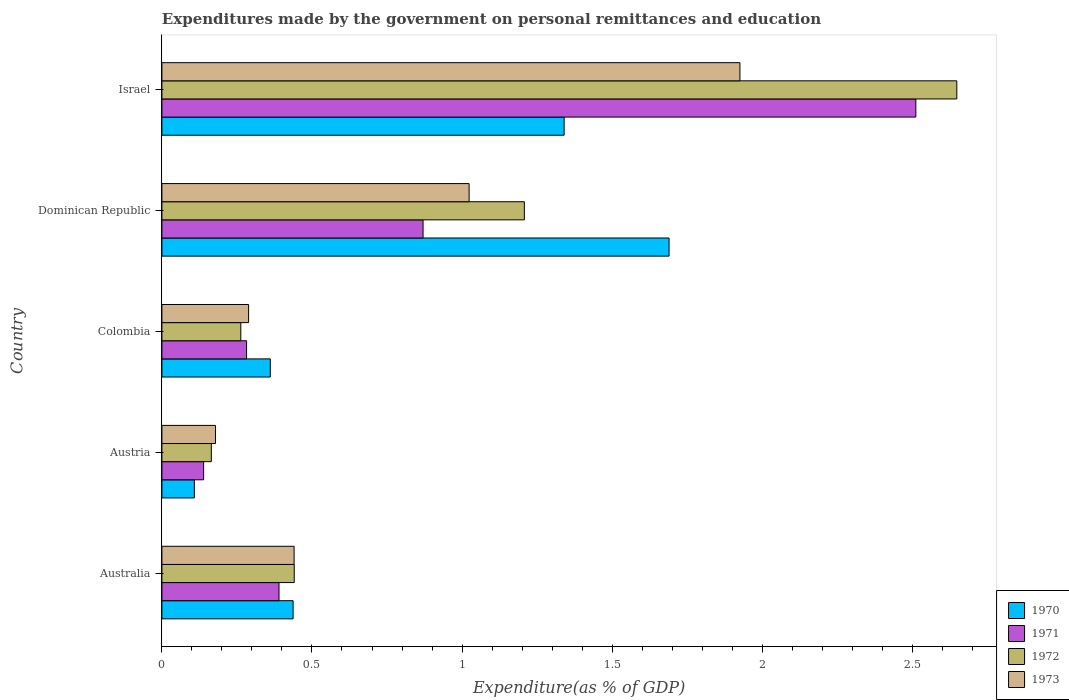How many groups of bars are there?
Your answer should be compact. 5. Are the number of bars per tick equal to the number of legend labels?
Your answer should be very brief. Yes. What is the label of the 2nd group of bars from the top?
Provide a short and direct response. Dominican Republic. In how many cases, is the number of bars for a given country not equal to the number of legend labels?
Provide a succinct answer. 0. What is the expenditures made by the government on personal remittances and education in 1973 in Australia?
Your answer should be compact. 0.44. Across all countries, what is the maximum expenditures made by the government on personal remittances and education in 1971?
Provide a succinct answer. 2.51. Across all countries, what is the minimum expenditures made by the government on personal remittances and education in 1971?
Keep it short and to the point. 0.14. What is the total expenditures made by the government on personal remittances and education in 1971 in the graph?
Ensure brevity in your answer.  4.19. What is the difference between the expenditures made by the government on personal remittances and education in 1971 in Australia and that in Dominican Republic?
Make the answer very short. -0.48. What is the difference between the expenditures made by the government on personal remittances and education in 1970 in Dominican Republic and the expenditures made by the government on personal remittances and education in 1971 in Israel?
Provide a short and direct response. -0.82. What is the average expenditures made by the government on personal remittances and education in 1973 per country?
Your response must be concise. 0.77. What is the difference between the expenditures made by the government on personal remittances and education in 1972 and expenditures made by the government on personal remittances and education in 1970 in Israel?
Keep it short and to the point. 1.31. In how many countries, is the expenditures made by the government on personal remittances and education in 1972 greater than 1.1 %?
Ensure brevity in your answer.  2. What is the ratio of the expenditures made by the government on personal remittances and education in 1973 in Colombia to that in Dominican Republic?
Offer a very short reply. 0.28. Is the expenditures made by the government on personal remittances and education in 1972 in Australia less than that in Colombia?
Provide a short and direct response. No. What is the difference between the highest and the second highest expenditures made by the government on personal remittances and education in 1972?
Keep it short and to the point. 1.44. What is the difference between the highest and the lowest expenditures made by the government on personal remittances and education in 1972?
Make the answer very short. 2.48. In how many countries, is the expenditures made by the government on personal remittances and education in 1970 greater than the average expenditures made by the government on personal remittances and education in 1970 taken over all countries?
Your response must be concise. 2. Is the sum of the expenditures made by the government on personal remittances and education in 1973 in Austria and Colombia greater than the maximum expenditures made by the government on personal remittances and education in 1972 across all countries?
Your answer should be compact. No. Is it the case that in every country, the sum of the expenditures made by the government on personal remittances and education in 1973 and expenditures made by the government on personal remittances and education in 1970 is greater than the sum of expenditures made by the government on personal remittances and education in 1972 and expenditures made by the government on personal remittances and education in 1971?
Keep it short and to the point. No. How many bars are there?
Offer a terse response. 20. Are the values on the major ticks of X-axis written in scientific E-notation?
Your response must be concise. No. What is the title of the graph?
Offer a terse response. Expenditures made by the government on personal remittances and education. What is the label or title of the X-axis?
Offer a very short reply. Expenditure(as % of GDP). What is the Expenditure(as % of GDP) in 1970 in Australia?
Keep it short and to the point. 0.44. What is the Expenditure(as % of GDP) in 1971 in Australia?
Offer a very short reply. 0.39. What is the Expenditure(as % of GDP) of 1972 in Australia?
Make the answer very short. 0.44. What is the Expenditure(as % of GDP) in 1973 in Australia?
Your answer should be compact. 0.44. What is the Expenditure(as % of GDP) of 1970 in Austria?
Keep it short and to the point. 0.11. What is the Expenditure(as % of GDP) of 1971 in Austria?
Make the answer very short. 0.14. What is the Expenditure(as % of GDP) in 1972 in Austria?
Your answer should be very brief. 0.16. What is the Expenditure(as % of GDP) of 1973 in Austria?
Offer a terse response. 0.18. What is the Expenditure(as % of GDP) in 1970 in Colombia?
Keep it short and to the point. 0.36. What is the Expenditure(as % of GDP) in 1971 in Colombia?
Give a very brief answer. 0.28. What is the Expenditure(as % of GDP) in 1972 in Colombia?
Make the answer very short. 0.26. What is the Expenditure(as % of GDP) in 1973 in Colombia?
Give a very brief answer. 0.29. What is the Expenditure(as % of GDP) in 1970 in Dominican Republic?
Offer a terse response. 1.69. What is the Expenditure(as % of GDP) in 1971 in Dominican Republic?
Your answer should be very brief. 0.87. What is the Expenditure(as % of GDP) of 1972 in Dominican Republic?
Provide a succinct answer. 1.21. What is the Expenditure(as % of GDP) in 1973 in Dominican Republic?
Your answer should be compact. 1.02. What is the Expenditure(as % of GDP) in 1970 in Israel?
Your answer should be compact. 1.34. What is the Expenditure(as % of GDP) in 1971 in Israel?
Provide a short and direct response. 2.51. What is the Expenditure(as % of GDP) of 1972 in Israel?
Ensure brevity in your answer.  2.65. What is the Expenditure(as % of GDP) in 1973 in Israel?
Your response must be concise. 1.93. Across all countries, what is the maximum Expenditure(as % of GDP) of 1970?
Provide a succinct answer. 1.69. Across all countries, what is the maximum Expenditure(as % of GDP) of 1971?
Your response must be concise. 2.51. Across all countries, what is the maximum Expenditure(as % of GDP) in 1972?
Give a very brief answer. 2.65. Across all countries, what is the maximum Expenditure(as % of GDP) in 1973?
Give a very brief answer. 1.93. Across all countries, what is the minimum Expenditure(as % of GDP) in 1970?
Keep it short and to the point. 0.11. Across all countries, what is the minimum Expenditure(as % of GDP) of 1971?
Provide a short and direct response. 0.14. Across all countries, what is the minimum Expenditure(as % of GDP) in 1972?
Provide a short and direct response. 0.16. Across all countries, what is the minimum Expenditure(as % of GDP) of 1973?
Ensure brevity in your answer.  0.18. What is the total Expenditure(as % of GDP) in 1970 in the graph?
Provide a succinct answer. 3.94. What is the total Expenditure(as % of GDP) in 1971 in the graph?
Offer a very short reply. 4.19. What is the total Expenditure(as % of GDP) of 1972 in the graph?
Give a very brief answer. 4.72. What is the total Expenditure(as % of GDP) in 1973 in the graph?
Keep it short and to the point. 3.86. What is the difference between the Expenditure(as % of GDP) in 1970 in Australia and that in Austria?
Give a very brief answer. 0.33. What is the difference between the Expenditure(as % of GDP) in 1971 in Australia and that in Austria?
Your response must be concise. 0.25. What is the difference between the Expenditure(as % of GDP) of 1972 in Australia and that in Austria?
Your answer should be very brief. 0.28. What is the difference between the Expenditure(as % of GDP) in 1973 in Australia and that in Austria?
Your response must be concise. 0.26. What is the difference between the Expenditure(as % of GDP) of 1970 in Australia and that in Colombia?
Ensure brevity in your answer.  0.08. What is the difference between the Expenditure(as % of GDP) of 1971 in Australia and that in Colombia?
Offer a terse response. 0.11. What is the difference between the Expenditure(as % of GDP) of 1972 in Australia and that in Colombia?
Your response must be concise. 0.18. What is the difference between the Expenditure(as % of GDP) in 1973 in Australia and that in Colombia?
Provide a succinct answer. 0.15. What is the difference between the Expenditure(as % of GDP) in 1970 in Australia and that in Dominican Republic?
Give a very brief answer. -1.25. What is the difference between the Expenditure(as % of GDP) in 1971 in Australia and that in Dominican Republic?
Give a very brief answer. -0.48. What is the difference between the Expenditure(as % of GDP) of 1972 in Australia and that in Dominican Republic?
Ensure brevity in your answer.  -0.77. What is the difference between the Expenditure(as % of GDP) in 1973 in Australia and that in Dominican Republic?
Your answer should be compact. -0.58. What is the difference between the Expenditure(as % of GDP) of 1970 in Australia and that in Israel?
Give a very brief answer. -0.9. What is the difference between the Expenditure(as % of GDP) in 1971 in Australia and that in Israel?
Make the answer very short. -2.12. What is the difference between the Expenditure(as % of GDP) of 1972 in Australia and that in Israel?
Provide a short and direct response. -2.21. What is the difference between the Expenditure(as % of GDP) of 1973 in Australia and that in Israel?
Ensure brevity in your answer.  -1.49. What is the difference between the Expenditure(as % of GDP) of 1970 in Austria and that in Colombia?
Offer a very short reply. -0.25. What is the difference between the Expenditure(as % of GDP) of 1971 in Austria and that in Colombia?
Give a very brief answer. -0.14. What is the difference between the Expenditure(as % of GDP) in 1972 in Austria and that in Colombia?
Provide a short and direct response. -0.1. What is the difference between the Expenditure(as % of GDP) of 1973 in Austria and that in Colombia?
Offer a very short reply. -0.11. What is the difference between the Expenditure(as % of GDP) in 1970 in Austria and that in Dominican Republic?
Provide a succinct answer. -1.58. What is the difference between the Expenditure(as % of GDP) of 1971 in Austria and that in Dominican Republic?
Offer a very short reply. -0.73. What is the difference between the Expenditure(as % of GDP) in 1972 in Austria and that in Dominican Republic?
Make the answer very short. -1.04. What is the difference between the Expenditure(as % of GDP) of 1973 in Austria and that in Dominican Republic?
Your answer should be compact. -0.84. What is the difference between the Expenditure(as % of GDP) of 1970 in Austria and that in Israel?
Your response must be concise. -1.23. What is the difference between the Expenditure(as % of GDP) of 1971 in Austria and that in Israel?
Your answer should be very brief. -2.37. What is the difference between the Expenditure(as % of GDP) of 1972 in Austria and that in Israel?
Provide a succinct answer. -2.48. What is the difference between the Expenditure(as % of GDP) in 1973 in Austria and that in Israel?
Make the answer very short. -1.75. What is the difference between the Expenditure(as % of GDP) of 1970 in Colombia and that in Dominican Republic?
Offer a very short reply. -1.33. What is the difference between the Expenditure(as % of GDP) of 1971 in Colombia and that in Dominican Republic?
Offer a terse response. -0.59. What is the difference between the Expenditure(as % of GDP) of 1972 in Colombia and that in Dominican Republic?
Offer a very short reply. -0.94. What is the difference between the Expenditure(as % of GDP) of 1973 in Colombia and that in Dominican Republic?
Make the answer very short. -0.73. What is the difference between the Expenditure(as % of GDP) in 1970 in Colombia and that in Israel?
Your answer should be very brief. -0.98. What is the difference between the Expenditure(as % of GDP) of 1971 in Colombia and that in Israel?
Ensure brevity in your answer.  -2.23. What is the difference between the Expenditure(as % of GDP) in 1972 in Colombia and that in Israel?
Make the answer very short. -2.39. What is the difference between the Expenditure(as % of GDP) in 1973 in Colombia and that in Israel?
Provide a succinct answer. -1.64. What is the difference between the Expenditure(as % of GDP) in 1970 in Dominican Republic and that in Israel?
Provide a succinct answer. 0.35. What is the difference between the Expenditure(as % of GDP) in 1971 in Dominican Republic and that in Israel?
Make the answer very short. -1.64. What is the difference between the Expenditure(as % of GDP) of 1972 in Dominican Republic and that in Israel?
Make the answer very short. -1.44. What is the difference between the Expenditure(as % of GDP) in 1973 in Dominican Republic and that in Israel?
Provide a short and direct response. -0.9. What is the difference between the Expenditure(as % of GDP) in 1970 in Australia and the Expenditure(as % of GDP) in 1971 in Austria?
Your response must be concise. 0.3. What is the difference between the Expenditure(as % of GDP) of 1970 in Australia and the Expenditure(as % of GDP) of 1972 in Austria?
Your response must be concise. 0.27. What is the difference between the Expenditure(as % of GDP) of 1970 in Australia and the Expenditure(as % of GDP) of 1973 in Austria?
Your response must be concise. 0.26. What is the difference between the Expenditure(as % of GDP) in 1971 in Australia and the Expenditure(as % of GDP) in 1972 in Austria?
Provide a succinct answer. 0.23. What is the difference between the Expenditure(as % of GDP) in 1971 in Australia and the Expenditure(as % of GDP) in 1973 in Austria?
Offer a terse response. 0.21. What is the difference between the Expenditure(as % of GDP) in 1972 in Australia and the Expenditure(as % of GDP) in 1973 in Austria?
Offer a very short reply. 0.26. What is the difference between the Expenditure(as % of GDP) in 1970 in Australia and the Expenditure(as % of GDP) in 1971 in Colombia?
Provide a succinct answer. 0.15. What is the difference between the Expenditure(as % of GDP) of 1970 in Australia and the Expenditure(as % of GDP) of 1972 in Colombia?
Offer a terse response. 0.17. What is the difference between the Expenditure(as % of GDP) of 1970 in Australia and the Expenditure(as % of GDP) of 1973 in Colombia?
Provide a short and direct response. 0.15. What is the difference between the Expenditure(as % of GDP) of 1971 in Australia and the Expenditure(as % of GDP) of 1972 in Colombia?
Offer a very short reply. 0.13. What is the difference between the Expenditure(as % of GDP) of 1971 in Australia and the Expenditure(as % of GDP) of 1973 in Colombia?
Provide a succinct answer. 0.1. What is the difference between the Expenditure(as % of GDP) of 1972 in Australia and the Expenditure(as % of GDP) of 1973 in Colombia?
Offer a very short reply. 0.15. What is the difference between the Expenditure(as % of GDP) in 1970 in Australia and the Expenditure(as % of GDP) in 1971 in Dominican Republic?
Offer a terse response. -0.43. What is the difference between the Expenditure(as % of GDP) of 1970 in Australia and the Expenditure(as % of GDP) of 1972 in Dominican Republic?
Keep it short and to the point. -0.77. What is the difference between the Expenditure(as % of GDP) of 1970 in Australia and the Expenditure(as % of GDP) of 1973 in Dominican Republic?
Provide a succinct answer. -0.59. What is the difference between the Expenditure(as % of GDP) of 1971 in Australia and the Expenditure(as % of GDP) of 1972 in Dominican Republic?
Your answer should be very brief. -0.82. What is the difference between the Expenditure(as % of GDP) in 1971 in Australia and the Expenditure(as % of GDP) in 1973 in Dominican Republic?
Ensure brevity in your answer.  -0.63. What is the difference between the Expenditure(as % of GDP) in 1972 in Australia and the Expenditure(as % of GDP) in 1973 in Dominican Republic?
Your response must be concise. -0.58. What is the difference between the Expenditure(as % of GDP) in 1970 in Australia and the Expenditure(as % of GDP) in 1971 in Israel?
Provide a short and direct response. -2.07. What is the difference between the Expenditure(as % of GDP) of 1970 in Australia and the Expenditure(as % of GDP) of 1972 in Israel?
Provide a succinct answer. -2.21. What is the difference between the Expenditure(as % of GDP) of 1970 in Australia and the Expenditure(as % of GDP) of 1973 in Israel?
Your response must be concise. -1.49. What is the difference between the Expenditure(as % of GDP) of 1971 in Australia and the Expenditure(as % of GDP) of 1972 in Israel?
Provide a succinct answer. -2.26. What is the difference between the Expenditure(as % of GDP) of 1971 in Australia and the Expenditure(as % of GDP) of 1973 in Israel?
Your answer should be very brief. -1.54. What is the difference between the Expenditure(as % of GDP) of 1972 in Australia and the Expenditure(as % of GDP) of 1973 in Israel?
Your answer should be very brief. -1.49. What is the difference between the Expenditure(as % of GDP) of 1970 in Austria and the Expenditure(as % of GDP) of 1971 in Colombia?
Offer a very short reply. -0.17. What is the difference between the Expenditure(as % of GDP) in 1970 in Austria and the Expenditure(as % of GDP) in 1972 in Colombia?
Offer a terse response. -0.15. What is the difference between the Expenditure(as % of GDP) in 1970 in Austria and the Expenditure(as % of GDP) in 1973 in Colombia?
Your answer should be very brief. -0.18. What is the difference between the Expenditure(as % of GDP) in 1971 in Austria and the Expenditure(as % of GDP) in 1972 in Colombia?
Make the answer very short. -0.12. What is the difference between the Expenditure(as % of GDP) in 1971 in Austria and the Expenditure(as % of GDP) in 1973 in Colombia?
Provide a short and direct response. -0.15. What is the difference between the Expenditure(as % of GDP) in 1972 in Austria and the Expenditure(as % of GDP) in 1973 in Colombia?
Offer a very short reply. -0.12. What is the difference between the Expenditure(as % of GDP) of 1970 in Austria and the Expenditure(as % of GDP) of 1971 in Dominican Republic?
Your response must be concise. -0.76. What is the difference between the Expenditure(as % of GDP) of 1970 in Austria and the Expenditure(as % of GDP) of 1972 in Dominican Republic?
Provide a short and direct response. -1.1. What is the difference between the Expenditure(as % of GDP) of 1970 in Austria and the Expenditure(as % of GDP) of 1973 in Dominican Republic?
Your answer should be compact. -0.92. What is the difference between the Expenditure(as % of GDP) of 1971 in Austria and the Expenditure(as % of GDP) of 1972 in Dominican Republic?
Keep it short and to the point. -1.07. What is the difference between the Expenditure(as % of GDP) of 1971 in Austria and the Expenditure(as % of GDP) of 1973 in Dominican Republic?
Keep it short and to the point. -0.88. What is the difference between the Expenditure(as % of GDP) of 1972 in Austria and the Expenditure(as % of GDP) of 1973 in Dominican Republic?
Offer a terse response. -0.86. What is the difference between the Expenditure(as % of GDP) in 1970 in Austria and the Expenditure(as % of GDP) in 1971 in Israel?
Offer a terse response. -2.4. What is the difference between the Expenditure(as % of GDP) in 1970 in Austria and the Expenditure(as % of GDP) in 1972 in Israel?
Offer a very short reply. -2.54. What is the difference between the Expenditure(as % of GDP) in 1970 in Austria and the Expenditure(as % of GDP) in 1973 in Israel?
Offer a very short reply. -1.82. What is the difference between the Expenditure(as % of GDP) of 1971 in Austria and the Expenditure(as % of GDP) of 1972 in Israel?
Your response must be concise. -2.51. What is the difference between the Expenditure(as % of GDP) of 1971 in Austria and the Expenditure(as % of GDP) of 1973 in Israel?
Provide a succinct answer. -1.79. What is the difference between the Expenditure(as % of GDP) of 1972 in Austria and the Expenditure(as % of GDP) of 1973 in Israel?
Your answer should be very brief. -1.76. What is the difference between the Expenditure(as % of GDP) in 1970 in Colombia and the Expenditure(as % of GDP) in 1971 in Dominican Republic?
Offer a very short reply. -0.51. What is the difference between the Expenditure(as % of GDP) of 1970 in Colombia and the Expenditure(as % of GDP) of 1972 in Dominican Republic?
Provide a succinct answer. -0.85. What is the difference between the Expenditure(as % of GDP) of 1970 in Colombia and the Expenditure(as % of GDP) of 1973 in Dominican Republic?
Provide a succinct answer. -0.66. What is the difference between the Expenditure(as % of GDP) in 1971 in Colombia and the Expenditure(as % of GDP) in 1972 in Dominican Republic?
Your response must be concise. -0.93. What is the difference between the Expenditure(as % of GDP) in 1971 in Colombia and the Expenditure(as % of GDP) in 1973 in Dominican Republic?
Provide a short and direct response. -0.74. What is the difference between the Expenditure(as % of GDP) in 1972 in Colombia and the Expenditure(as % of GDP) in 1973 in Dominican Republic?
Ensure brevity in your answer.  -0.76. What is the difference between the Expenditure(as % of GDP) in 1970 in Colombia and the Expenditure(as % of GDP) in 1971 in Israel?
Offer a very short reply. -2.15. What is the difference between the Expenditure(as % of GDP) of 1970 in Colombia and the Expenditure(as % of GDP) of 1972 in Israel?
Offer a very short reply. -2.29. What is the difference between the Expenditure(as % of GDP) of 1970 in Colombia and the Expenditure(as % of GDP) of 1973 in Israel?
Your answer should be very brief. -1.56. What is the difference between the Expenditure(as % of GDP) in 1971 in Colombia and the Expenditure(as % of GDP) in 1972 in Israel?
Provide a succinct answer. -2.37. What is the difference between the Expenditure(as % of GDP) in 1971 in Colombia and the Expenditure(as % of GDP) in 1973 in Israel?
Provide a short and direct response. -1.64. What is the difference between the Expenditure(as % of GDP) in 1972 in Colombia and the Expenditure(as % of GDP) in 1973 in Israel?
Offer a very short reply. -1.66. What is the difference between the Expenditure(as % of GDP) in 1970 in Dominican Republic and the Expenditure(as % of GDP) in 1971 in Israel?
Keep it short and to the point. -0.82. What is the difference between the Expenditure(as % of GDP) in 1970 in Dominican Republic and the Expenditure(as % of GDP) in 1972 in Israel?
Provide a short and direct response. -0.96. What is the difference between the Expenditure(as % of GDP) in 1970 in Dominican Republic and the Expenditure(as % of GDP) in 1973 in Israel?
Give a very brief answer. -0.24. What is the difference between the Expenditure(as % of GDP) of 1971 in Dominican Republic and the Expenditure(as % of GDP) of 1972 in Israel?
Offer a very short reply. -1.78. What is the difference between the Expenditure(as % of GDP) of 1971 in Dominican Republic and the Expenditure(as % of GDP) of 1973 in Israel?
Ensure brevity in your answer.  -1.06. What is the difference between the Expenditure(as % of GDP) in 1972 in Dominican Republic and the Expenditure(as % of GDP) in 1973 in Israel?
Provide a succinct answer. -0.72. What is the average Expenditure(as % of GDP) of 1970 per country?
Your answer should be compact. 0.79. What is the average Expenditure(as % of GDP) in 1971 per country?
Your answer should be compact. 0.84. What is the average Expenditure(as % of GDP) in 1972 per country?
Your response must be concise. 0.94. What is the average Expenditure(as % of GDP) in 1973 per country?
Offer a very short reply. 0.77. What is the difference between the Expenditure(as % of GDP) of 1970 and Expenditure(as % of GDP) of 1971 in Australia?
Give a very brief answer. 0.05. What is the difference between the Expenditure(as % of GDP) of 1970 and Expenditure(as % of GDP) of 1972 in Australia?
Your answer should be very brief. -0. What is the difference between the Expenditure(as % of GDP) of 1970 and Expenditure(as % of GDP) of 1973 in Australia?
Make the answer very short. -0. What is the difference between the Expenditure(as % of GDP) in 1971 and Expenditure(as % of GDP) in 1972 in Australia?
Your response must be concise. -0.05. What is the difference between the Expenditure(as % of GDP) of 1971 and Expenditure(as % of GDP) of 1973 in Australia?
Make the answer very short. -0.05. What is the difference between the Expenditure(as % of GDP) in 1972 and Expenditure(as % of GDP) in 1973 in Australia?
Offer a terse response. 0. What is the difference between the Expenditure(as % of GDP) of 1970 and Expenditure(as % of GDP) of 1971 in Austria?
Offer a terse response. -0.03. What is the difference between the Expenditure(as % of GDP) in 1970 and Expenditure(as % of GDP) in 1972 in Austria?
Offer a terse response. -0.06. What is the difference between the Expenditure(as % of GDP) of 1970 and Expenditure(as % of GDP) of 1973 in Austria?
Provide a short and direct response. -0.07. What is the difference between the Expenditure(as % of GDP) in 1971 and Expenditure(as % of GDP) in 1972 in Austria?
Ensure brevity in your answer.  -0.03. What is the difference between the Expenditure(as % of GDP) of 1971 and Expenditure(as % of GDP) of 1973 in Austria?
Provide a succinct answer. -0.04. What is the difference between the Expenditure(as % of GDP) in 1972 and Expenditure(as % of GDP) in 1973 in Austria?
Offer a very short reply. -0.01. What is the difference between the Expenditure(as % of GDP) of 1970 and Expenditure(as % of GDP) of 1971 in Colombia?
Offer a terse response. 0.08. What is the difference between the Expenditure(as % of GDP) in 1970 and Expenditure(as % of GDP) in 1972 in Colombia?
Your response must be concise. 0.1. What is the difference between the Expenditure(as % of GDP) in 1970 and Expenditure(as % of GDP) in 1973 in Colombia?
Your response must be concise. 0.07. What is the difference between the Expenditure(as % of GDP) in 1971 and Expenditure(as % of GDP) in 1972 in Colombia?
Keep it short and to the point. 0.02. What is the difference between the Expenditure(as % of GDP) of 1971 and Expenditure(as % of GDP) of 1973 in Colombia?
Offer a very short reply. -0.01. What is the difference between the Expenditure(as % of GDP) in 1972 and Expenditure(as % of GDP) in 1973 in Colombia?
Your answer should be compact. -0.03. What is the difference between the Expenditure(as % of GDP) in 1970 and Expenditure(as % of GDP) in 1971 in Dominican Republic?
Your response must be concise. 0.82. What is the difference between the Expenditure(as % of GDP) of 1970 and Expenditure(as % of GDP) of 1972 in Dominican Republic?
Your response must be concise. 0.48. What is the difference between the Expenditure(as % of GDP) of 1970 and Expenditure(as % of GDP) of 1973 in Dominican Republic?
Offer a very short reply. 0.67. What is the difference between the Expenditure(as % of GDP) of 1971 and Expenditure(as % of GDP) of 1972 in Dominican Republic?
Offer a very short reply. -0.34. What is the difference between the Expenditure(as % of GDP) in 1971 and Expenditure(as % of GDP) in 1973 in Dominican Republic?
Keep it short and to the point. -0.15. What is the difference between the Expenditure(as % of GDP) in 1972 and Expenditure(as % of GDP) in 1973 in Dominican Republic?
Your answer should be very brief. 0.18. What is the difference between the Expenditure(as % of GDP) of 1970 and Expenditure(as % of GDP) of 1971 in Israel?
Give a very brief answer. -1.17. What is the difference between the Expenditure(as % of GDP) of 1970 and Expenditure(as % of GDP) of 1972 in Israel?
Make the answer very short. -1.31. What is the difference between the Expenditure(as % of GDP) of 1970 and Expenditure(as % of GDP) of 1973 in Israel?
Ensure brevity in your answer.  -0.59. What is the difference between the Expenditure(as % of GDP) in 1971 and Expenditure(as % of GDP) in 1972 in Israel?
Keep it short and to the point. -0.14. What is the difference between the Expenditure(as % of GDP) of 1971 and Expenditure(as % of GDP) of 1973 in Israel?
Your answer should be very brief. 0.59. What is the difference between the Expenditure(as % of GDP) in 1972 and Expenditure(as % of GDP) in 1973 in Israel?
Offer a terse response. 0.72. What is the ratio of the Expenditure(as % of GDP) of 1970 in Australia to that in Austria?
Provide a succinct answer. 4.04. What is the ratio of the Expenditure(as % of GDP) of 1971 in Australia to that in Austria?
Your answer should be very brief. 2.81. What is the ratio of the Expenditure(as % of GDP) in 1972 in Australia to that in Austria?
Your answer should be very brief. 2.68. What is the ratio of the Expenditure(as % of GDP) in 1973 in Australia to that in Austria?
Your answer should be very brief. 2.47. What is the ratio of the Expenditure(as % of GDP) in 1970 in Australia to that in Colombia?
Offer a terse response. 1.21. What is the ratio of the Expenditure(as % of GDP) in 1971 in Australia to that in Colombia?
Provide a short and direct response. 1.38. What is the ratio of the Expenditure(as % of GDP) in 1972 in Australia to that in Colombia?
Your response must be concise. 1.68. What is the ratio of the Expenditure(as % of GDP) in 1973 in Australia to that in Colombia?
Offer a terse response. 1.52. What is the ratio of the Expenditure(as % of GDP) in 1970 in Australia to that in Dominican Republic?
Offer a very short reply. 0.26. What is the ratio of the Expenditure(as % of GDP) of 1971 in Australia to that in Dominican Republic?
Your response must be concise. 0.45. What is the ratio of the Expenditure(as % of GDP) in 1972 in Australia to that in Dominican Republic?
Make the answer very short. 0.37. What is the ratio of the Expenditure(as % of GDP) in 1973 in Australia to that in Dominican Republic?
Offer a very short reply. 0.43. What is the ratio of the Expenditure(as % of GDP) of 1970 in Australia to that in Israel?
Your answer should be compact. 0.33. What is the ratio of the Expenditure(as % of GDP) of 1971 in Australia to that in Israel?
Provide a succinct answer. 0.16. What is the ratio of the Expenditure(as % of GDP) of 1972 in Australia to that in Israel?
Ensure brevity in your answer.  0.17. What is the ratio of the Expenditure(as % of GDP) of 1973 in Australia to that in Israel?
Your answer should be compact. 0.23. What is the ratio of the Expenditure(as % of GDP) of 1970 in Austria to that in Colombia?
Make the answer very short. 0.3. What is the ratio of the Expenditure(as % of GDP) of 1971 in Austria to that in Colombia?
Offer a terse response. 0.49. What is the ratio of the Expenditure(as % of GDP) of 1972 in Austria to that in Colombia?
Ensure brevity in your answer.  0.63. What is the ratio of the Expenditure(as % of GDP) in 1973 in Austria to that in Colombia?
Ensure brevity in your answer.  0.62. What is the ratio of the Expenditure(as % of GDP) of 1970 in Austria to that in Dominican Republic?
Your answer should be compact. 0.06. What is the ratio of the Expenditure(as % of GDP) in 1971 in Austria to that in Dominican Republic?
Your answer should be very brief. 0.16. What is the ratio of the Expenditure(as % of GDP) of 1972 in Austria to that in Dominican Republic?
Provide a short and direct response. 0.14. What is the ratio of the Expenditure(as % of GDP) in 1973 in Austria to that in Dominican Republic?
Offer a very short reply. 0.17. What is the ratio of the Expenditure(as % of GDP) of 1970 in Austria to that in Israel?
Make the answer very short. 0.08. What is the ratio of the Expenditure(as % of GDP) in 1971 in Austria to that in Israel?
Your answer should be compact. 0.06. What is the ratio of the Expenditure(as % of GDP) of 1972 in Austria to that in Israel?
Give a very brief answer. 0.06. What is the ratio of the Expenditure(as % of GDP) in 1973 in Austria to that in Israel?
Offer a terse response. 0.09. What is the ratio of the Expenditure(as % of GDP) of 1970 in Colombia to that in Dominican Republic?
Your answer should be compact. 0.21. What is the ratio of the Expenditure(as % of GDP) in 1971 in Colombia to that in Dominican Republic?
Offer a terse response. 0.32. What is the ratio of the Expenditure(as % of GDP) in 1972 in Colombia to that in Dominican Republic?
Make the answer very short. 0.22. What is the ratio of the Expenditure(as % of GDP) in 1973 in Colombia to that in Dominican Republic?
Ensure brevity in your answer.  0.28. What is the ratio of the Expenditure(as % of GDP) of 1970 in Colombia to that in Israel?
Provide a succinct answer. 0.27. What is the ratio of the Expenditure(as % of GDP) in 1971 in Colombia to that in Israel?
Provide a succinct answer. 0.11. What is the ratio of the Expenditure(as % of GDP) of 1972 in Colombia to that in Israel?
Give a very brief answer. 0.1. What is the ratio of the Expenditure(as % of GDP) in 1970 in Dominican Republic to that in Israel?
Ensure brevity in your answer.  1.26. What is the ratio of the Expenditure(as % of GDP) in 1971 in Dominican Republic to that in Israel?
Give a very brief answer. 0.35. What is the ratio of the Expenditure(as % of GDP) in 1972 in Dominican Republic to that in Israel?
Offer a terse response. 0.46. What is the ratio of the Expenditure(as % of GDP) of 1973 in Dominican Republic to that in Israel?
Offer a very short reply. 0.53. What is the difference between the highest and the second highest Expenditure(as % of GDP) of 1970?
Ensure brevity in your answer.  0.35. What is the difference between the highest and the second highest Expenditure(as % of GDP) of 1971?
Your response must be concise. 1.64. What is the difference between the highest and the second highest Expenditure(as % of GDP) in 1972?
Your answer should be very brief. 1.44. What is the difference between the highest and the second highest Expenditure(as % of GDP) in 1973?
Give a very brief answer. 0.9. What is the difference between the highest and the lowest Expenditure(as % of GDP) of 1970?
Your answer should be compact. 1.58. What is the difference between the highest and the lowest Expenditure(as % of GDP) in 1971?
Keep it short and to the point. 2.37. What is the difference between the highest and the lowest Expenditure(as % of GDP) in 1972?
Keep it short and to the point. 2.48. What is the difference between the highest and the lowest Expenditure(as % of GDP) in 1973?
Offer a terse response. 1.75. 